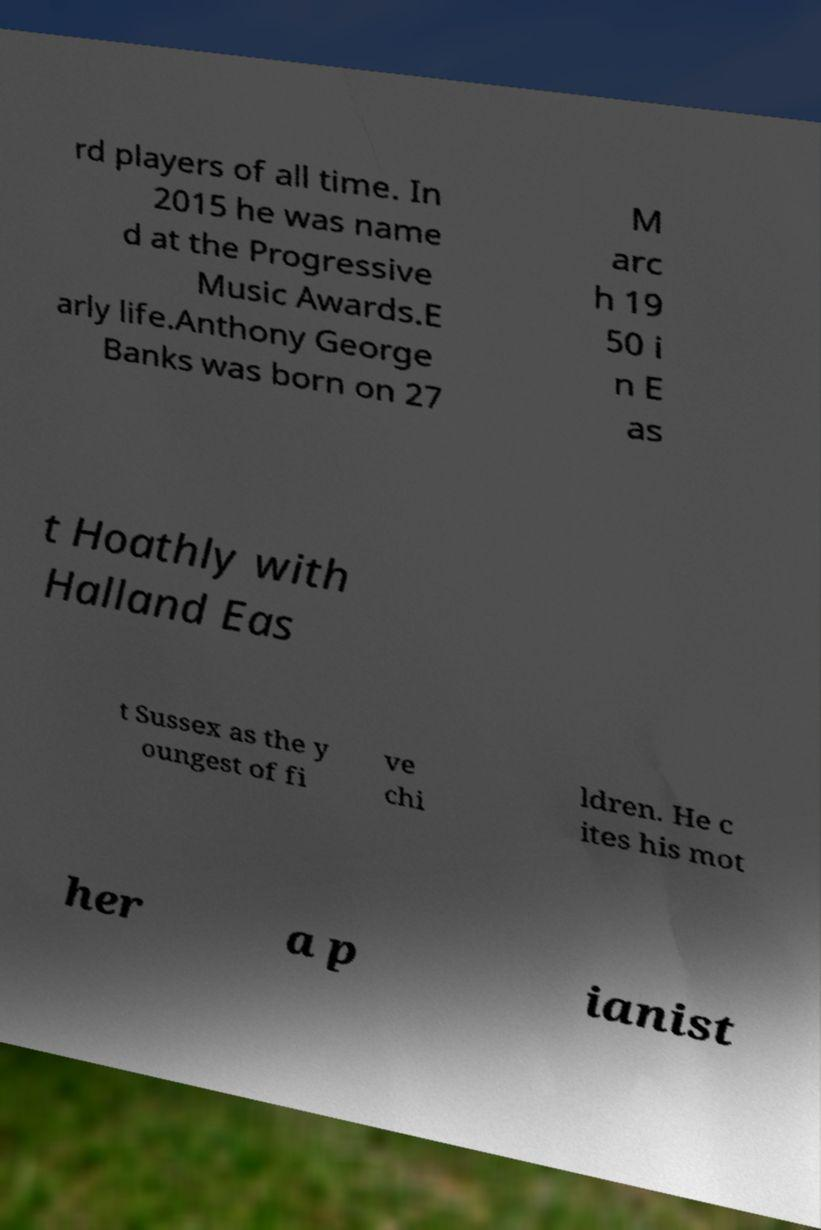What messages or text are displayed in this image? I need them in a readable, typed format. rd players of all time. In 2015 he was name d at the Progressive Music Awards.E arly life.Anthony George Banks was born on 27 M arc h 19 50 i n E as t Hoathly with Halland Eas t Sussex as the y oungest of fi ve chi ldren. He c ites his mot her a p ianist 